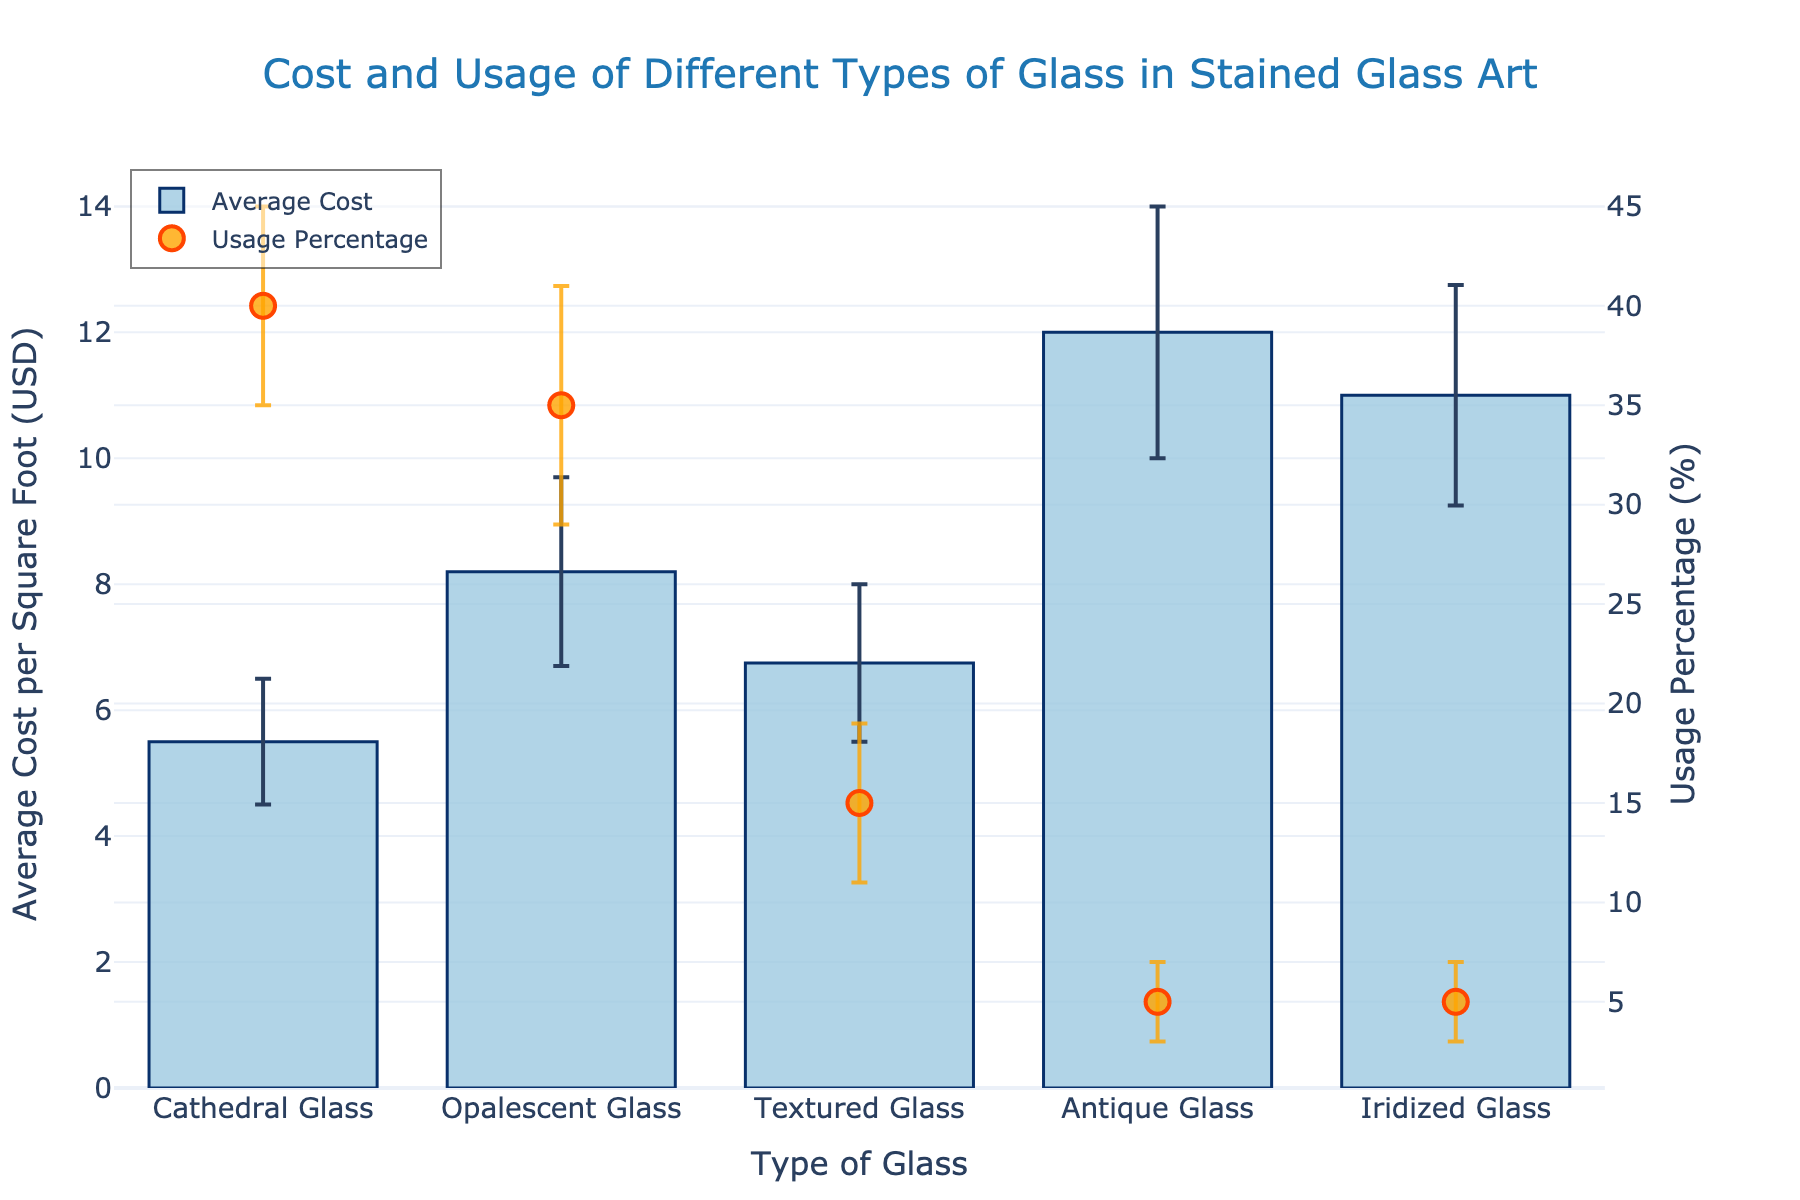What is the title of the plot? The title of the plot is located at the top of the figure and is used to provide a brief description of what the plot is about.
Answer: Cost and Usage of Different Types of Glass in Stained Glass Art What colors are used for the markers representing the usage percentage? The markers for the usage percentage are displayed as scatter plot points. They are colored with a fill of light orange and a border color of red.
Answer: Light orange and red Which type of glass has the highest average cost per square foot? To find this, look at the bar heights representing the average cost. The tallest bar corresponds to the highest average cost.
Answer: Antique Glass What is the average cost per square foot for Opalescent Glass and what is its error range? Identify the bar corresponding to Opalescent Glass and note its height (average cost) and error bar range indicating standard deviation vertically upwards and downwards.
Answer: 8.20 USD, error range of +/- 1.5 USD What is the combined percentage usage of Antique Glass and Iridized Glass? To find the combined usage percentage, add the usage percentages of both types of glass.
Answer: 5% + 5% = 10% Which type of glass is used the most in stained glass projects? Look for the data point with the highest usage percentage in the scatter plot.
Answer: Cathedral Glass How does the standard deviation of the cost for Textured Glass compare to that for Iridized Glass? Check the error bars depicting cost variability. The one with the larger vertical line indicates a higher standard deviation.
Answer: Textured Glass: 1.25, Iridized Glass: 1.75; Iridized Glass has a higher standard deviation Which type of glass shows the largest variation in usage percentage? The size of the error bars in the scatter plot indicates the variation. Identify the type with the largest error bar.
Answer: Opalescent Glass What is the average usage percentage of all types of glass combined? To calculate this, sum all the usage percentages and divide by the number of glass types.
Answer: (40% + 35% + 15% + 5% + 5%) / 5 = 20% Is there a correlation between average cost per square foot and usage percentage? To determine this, compare the trends in the bar heights and scatter points. A visible pattern across the plot suggests correlation or lack thereof.
Answer: No clear correlation 